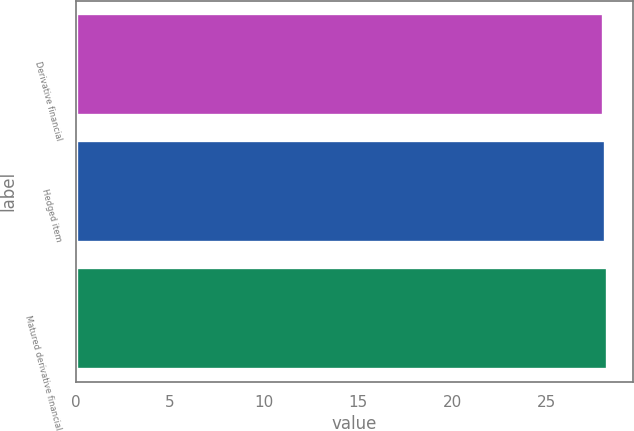Convert chart. <chart><loc_0><loc_0><loc_500><loc_500><bar_chart><fcel>Derivative financial<fcel>Hedged item<fcel>Matured derivative financial<nl><fcel>28<fcel>28.1<fcel>28.2<nl></chart> 